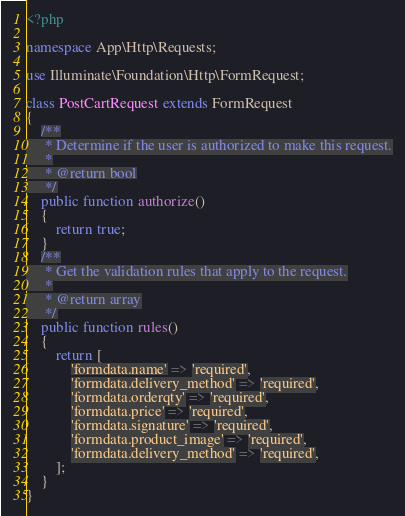<code> <loc_0><loc_0><loc_500><loc_500><_PHP_><?php

namespace App\Http\Requests;

use Illuminate\Foundation\Http\FormRequest;

class PostCartRequest extends FormRequest
{
    /**
     * Determine if the user is authorized to make this request.
     *
     * @return bool
     */
    public function authorize()
    {
        return true;
    }
    /**
     * Get the validation rules that apply to the request.
     *
     * @return array
     */
    public function rules()
    {
        return [
            'formdata.name' => 'required',
            'formdata.delivery_method' => 'required',
            'formdata.orderqty' => 'required',
            'formdata.price' => 'required',
            'formdata.signature' => 'required',
            'formdata.product_image' => 'required',
            'formdata.delivery_method' => 'required',
        ];
    }
}
</code> 